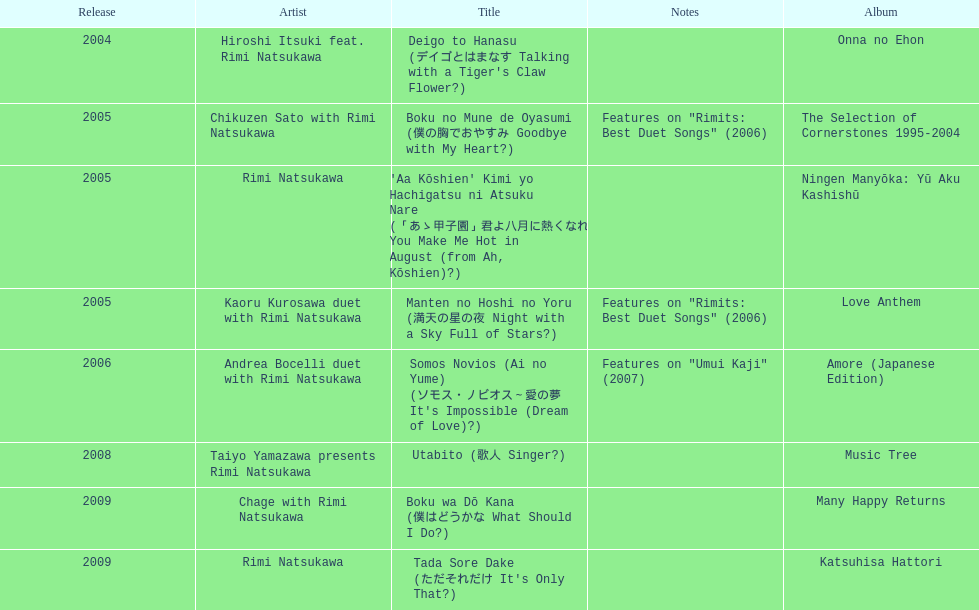Which was unveiled earlier, deigo to hanasu or utabito? Deigo to Hanasu. 